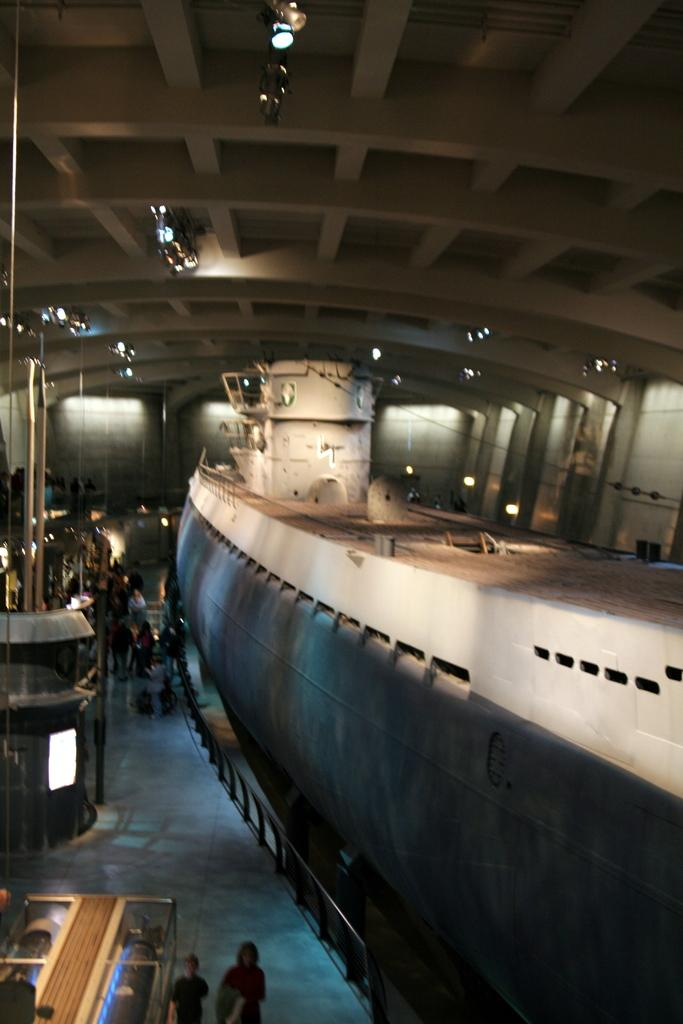What is the main subject of the image? There is a ship in the image. What else can be seen in the image besides the ship? There are people on the floor and lights in the background of the image. What type of structure is visible in the background? There is a wall in the background of the image. How many balls are being juggled by the people on the floor in the image? There are no balls visible in the image; the people on the floor are not juggling anything. 